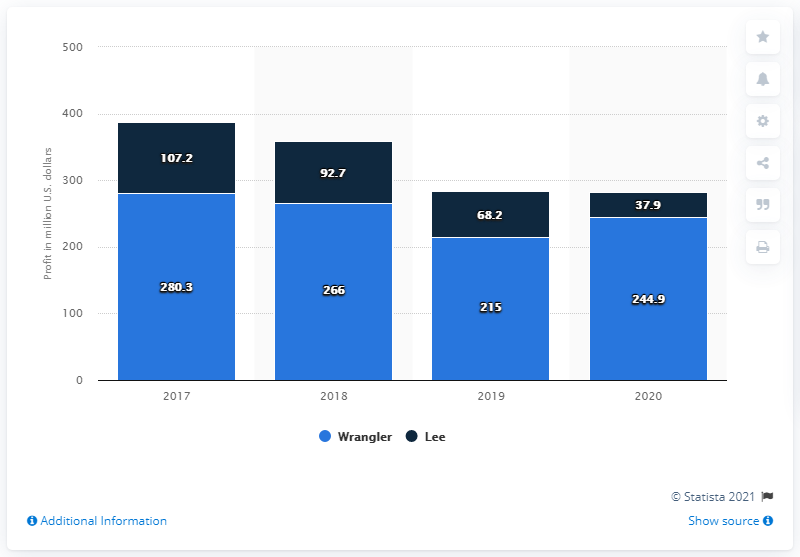How much money did the Wrangler brand make in the U.S. in 2020? In 2020, the Wrangler brand generated revenues of $244.9 million in the U.S., according to the data depicted in the bar chart. 